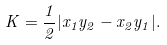<formula> <loc_0><loc_0><loc_500><loc_500>K = { \frac { 1 } { 2 } } | x _ { 1 } y _ { 2 } - x _ { 2 } y _ { 1 } | .</formula> 